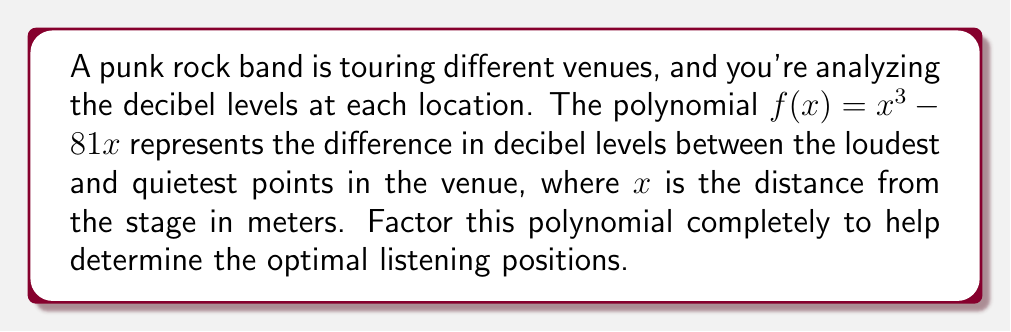Could you help me with this problem? Let's approach this step-by-step:

1) First, we can factor out the greatest common factor (GCF):
   $f(x) = x^3 - 81x = x(x^2 - 81)$

2) Now, we focus on the factor $(x^2 - 81)$. This is a difference of squares, which can be factored as $(a+b)(a-b)$ where $a^2$ is the first term and $b^2$ is the second term.

3) In this case, $a^2 = x^2$ and $b^2 = 81$, so $a = x$ and $b = 9$:
   $x^2 - 81 = (x+9)(x-9)$

4) Putting it all together:
   $f(x) = x(x^2 - 81) = x(x+9)(x-9)$

Therefore, the polynomial $x^3 - 81x$ factors completely into $x(x+9)(x-9)$.

This factorization tells us that the difference in decibel levels is zero (i.e., the sound level is uniform) at three distances from the stage: 0 meters (at the stage itself), 9 meters in front of the stage, and 9 meters behind the stage (if that were possible in a venue setting).
Answer: $x(x+9)(x-9)$ 